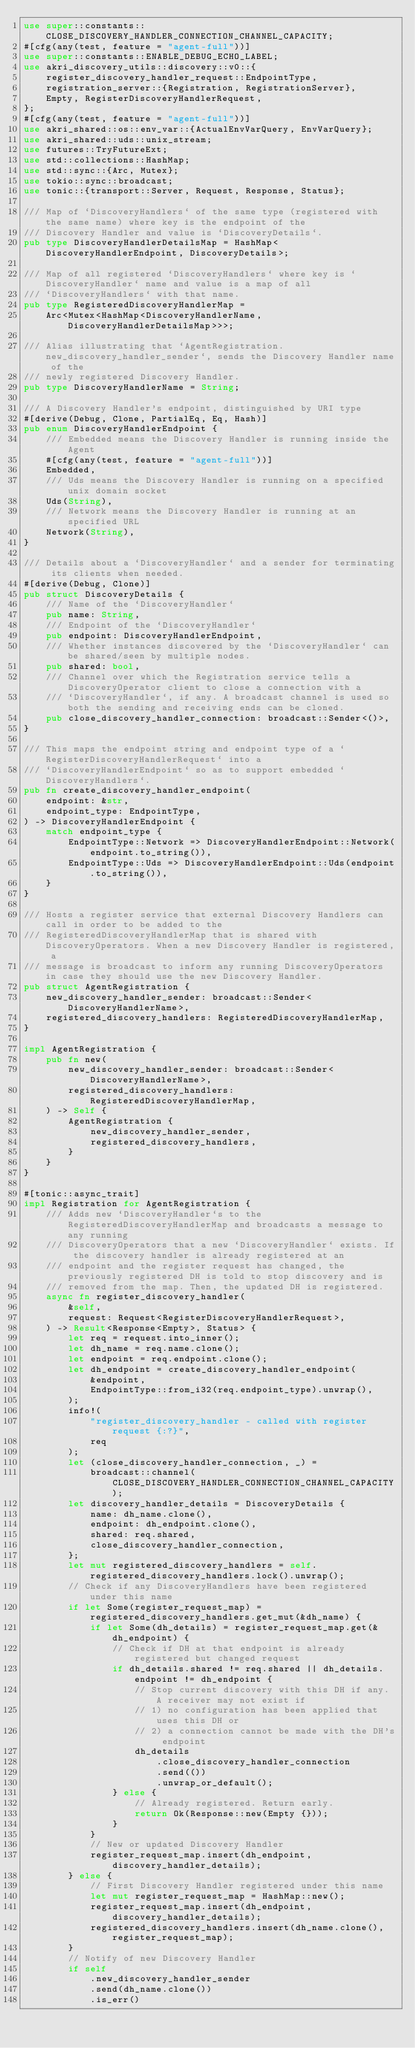<code> <loc_0><loc_0><loc_500><loc_500><_Rust_>use super::constants::CLOSE_DISCOVERY_HANDLER_CONNECTION_CHANNEL_CAPACITY;
#[cfg(any(test, feature = "agent-full"))]
use super::constants::ENABLE_DEBUG_ECHO_LABEL;
use akri_discovery_utils::discovery::v0::{
    register_discovery_handler_request::EndpointType,
    registration_server::{Registration, RegistrationServer},
    Empty, RegisterDiscoveryHandlerRequest,
};
#[cfg(any(test, feature = "agent-full"))]
use akri_shared::os::env_var::{ActualEnvVarQuery, EnvVarQuery};
use akri_shared::uds::unix_stream;
use futures::TryFutureExt;
use std::collections::HashMap;
use std::sync::{Arc, Mutex};
use tokio::sync::broadcast;
use tonic::{transport::Server, Request, Response, Status};

/// Map of `DiscoveryHandlers` of the same type (registered with the same name) where key is the endpoint of the
/// Discovery Handler and value is `DiscoveryDetails`.
pub type DiscoveryHandlerDetailsMap = HashMap<DiscoveryHandlerEndpoint, DiscoveryDetails>;

/// Map of all registered `DiscoveryHandlers` where key is `DiscoveryHandler` name and value is a map of all
/// `DiscoveryHandlers` with that name.
pub type RegisteredDiscoveryHandlerMap =
    Arc<Mutex<HashMap<DiscoveryHandlerName, DiscoveryHandlerDetailsMap>>>;

/// Alias illustrating that `AgentRegistration.new_discovery_handler_sender`, sends the Discovery Handler name of the
/// newly registered Discovery Handler.
pub type DiscoveryHandlerName = String;

/// A Discovery Handler's endpoint, distinguished by URI type
#[derive(Debug, Clone, PartialEq, Eq, Hash)]
pub enum DiscoveryHandlerEndpoint {
    /// Embedded means the Discovery Handler is running inside the Agent
    #[cfg(any(test, feature = "agent-full"))]
    Embedded,
    /// Uds means the Discovery Handler is running on a specified unix domain socket
    Uds(String),
    /// Network means the Discovery Handler is running at an specified URL
    Network(String),
}

/// Details about a `DiscoveryHandler` and a sender for terminating its clients when needed.
#[derive(Debug, Clone)]
pub struct DiscoveryDetails {
    /// Name of the `DiscoveryHandler`
    pub name: String,
    /// Endpoint of the `DiscoveryHandler`
    pub endpoint: DiscoveryHandlerEndpoint,
    /// Whether instances discovered by the `DiscoveryHandler` can be shared/seen by multiple nodes.
    pub shared: bool,
    /// Channel over which the Registration service tells a DiscoveryOperator client to close a connection with a
    /// `DiscoveryHandler`, if any. A broadcast channel is used so both the sending and receiving ends can be cloned.
    pub close_discovery_handler_connection: broadcast::Sender<()>,
}

/// This maps the endpoint string and endpoint type of a `RegisterDiscoveryHandlerRequest` into a
/// `DiscoveryHandlerEndpoint` so as to support embedded `DiscoveryHandlers`.
pub fn create_discovery_handler_endpoint(
    endpoint: &str,
    endpoint_type: EndpointType,
) -> DiscoveryHandlerEndpoint {
    match endpoint_type {
        EndpointType::Network => DiscoveryHandlerEndpoint::Network(endpoint.to_string()),
        EndpointType::Uds => DiscoveryHandlerEndpoint::Uds(endpoint.to_string()),
    }
}

/// Hosts a register service that external Discovery Handlers can call in order to be added to the
/// RegisteredDiscoveryHandlerMap that is shared with DiscoveryOperators. When a new Discovery Handler is registered, a
/// message is broadcast to inform any running DiscoveryOperators in case they should use the new Discovery Handler.
pub struct AgentRegistration {
    new_discovery_handler_sender: broadcast::Sender<DiscoveryHandlerName>,
    registered_discovery_handlers: RegisteredDiscoveryHandlerMap,
}

impl AgentRegistration {
    pub fn new(
        new_discovery_handler_sender: broadcast::Sender<DiscoveryHandlerName>,
        registered_discovery_handlers: RegisteredDiscoveryHandlerMap,
    ) -> Self {
        AgentRegistration {
            new_discovery_handler_sender,
            registered_discovery_handlers,
        }
    }
}

#[tonic::async_trait]
impl Registration for AgentRegistration {
    /// Adds new `DiscoveryHandler`s to the RegisteredDiscoveryHandlerMap and broadcasts a message to any running
    /// DiscoveryOperators that a new `DiscoveryHandler` exists. If the discovery handler is already registered at an
    /// endpoint and the register request has changed, the previously registered DH is told to stop discovery and is
    /// removed from the map. Then, the updated DH is registered.
    async fn register_discovery_handler(
        &self,
        request: Request<RegisterDiscoveryHandlerRequest>,
    ) -> Result<Response<Empty>, Status> {
        let req = request.into_inner();
        let dh_name = req.name.clone();
        let endpoint = req.endpoint.clone();
        let dh_endpoint = create_discovery_handler_endpoint(
            &endpoint,
            EndpointType::from_i32(req.endpoint_type).unwrap(),
        );
        info!(
            "register_discovery_handler - called with register request {:?}",
            req
        );
        let (close_discovery_handler_connection, _) =
            broadcast::channel(CLOSE_DISCOVERY_HANDLER_CONNECTION_CHANNEL_CAPACITY);
        let discovery_handler_details = DiscoveryDetails {
            name: dh_name.clone(),
            endpoint: dh_endpoint.clone(),
            shared: req.shared,
            close_discovery_handler_connection,
        };
        let mut registered_discovery_handlers = self.registered_discovery_handlers.lock().unwrap();
        // Check if any DiscoveryHandlers have been registered under this name
        if let Some(register_request_map) = registered_discovery_handlers.get_mut(&dh_name) {
            if let Some(dh_details) = register_request_map.get(&dh_endpoint) {
                // Check if DH at that endpoint is already registered but changed request
                if dh_details.shared != req.shared || dh_details.endpoint != dh_endpoint {
                    // Stop current discovery with this DH if any. A receiver may not exist if
                    // 1) no configuration has been applied that uses this DH or
                    // 2) a connection cannot be made with the DH's endpoint
                    dh_details
                        .close_discovery_handler_connection
                        .send(())
                        .unwrap_or_default();
                } else {
                    // Already registered. Return early.
                    return Ok(Response::new(Empty {}));
                }
            }
            // New or updated Discovery Handler
            register_request_map.insert(dh_endpoint, discovery_handler_details);
        } else {
            // First Discovery Handler registered under this name
            let mut register_request_map = HashMap::new();
            register_request_map.insert(dh_endpoint, discovery_handler_details);
            registered_discovery_handlers.insert(dh_name.clone(), register_request_map);
        }
        // Notify of new Discovery Handler
        if self
            .new_discovery_handler_sender
            .send(dh_name.clone())
            .is_err()</code> 